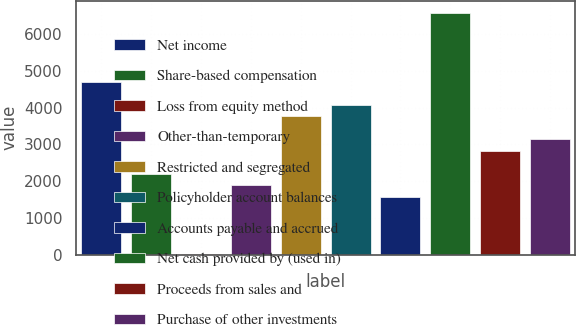Convert chart to OTSL. <chart><loc_0><loc_0><loc_500><loc_500><bar_chart><fcel>Net income<fcel>Share-based compensation<fcel>Loss from equity method<fcel>Other-than-temporary<fcel>Restricted and segregated<fcel>Policyholder account balances<fcel>Accounts payable and accrued<fcel>Net cash provided by (used in)<fcel>Proceeds from sales and<fcel>Purchase of other investments<nl><fcel>4701.5<fcel>2201.5<fcel>14<fcel>1889<fcel>3764<fcel>4076.5<fcel>1576.5<fcel>6576.5<fcel>2826.5<fcel>3139<nl></chart> 